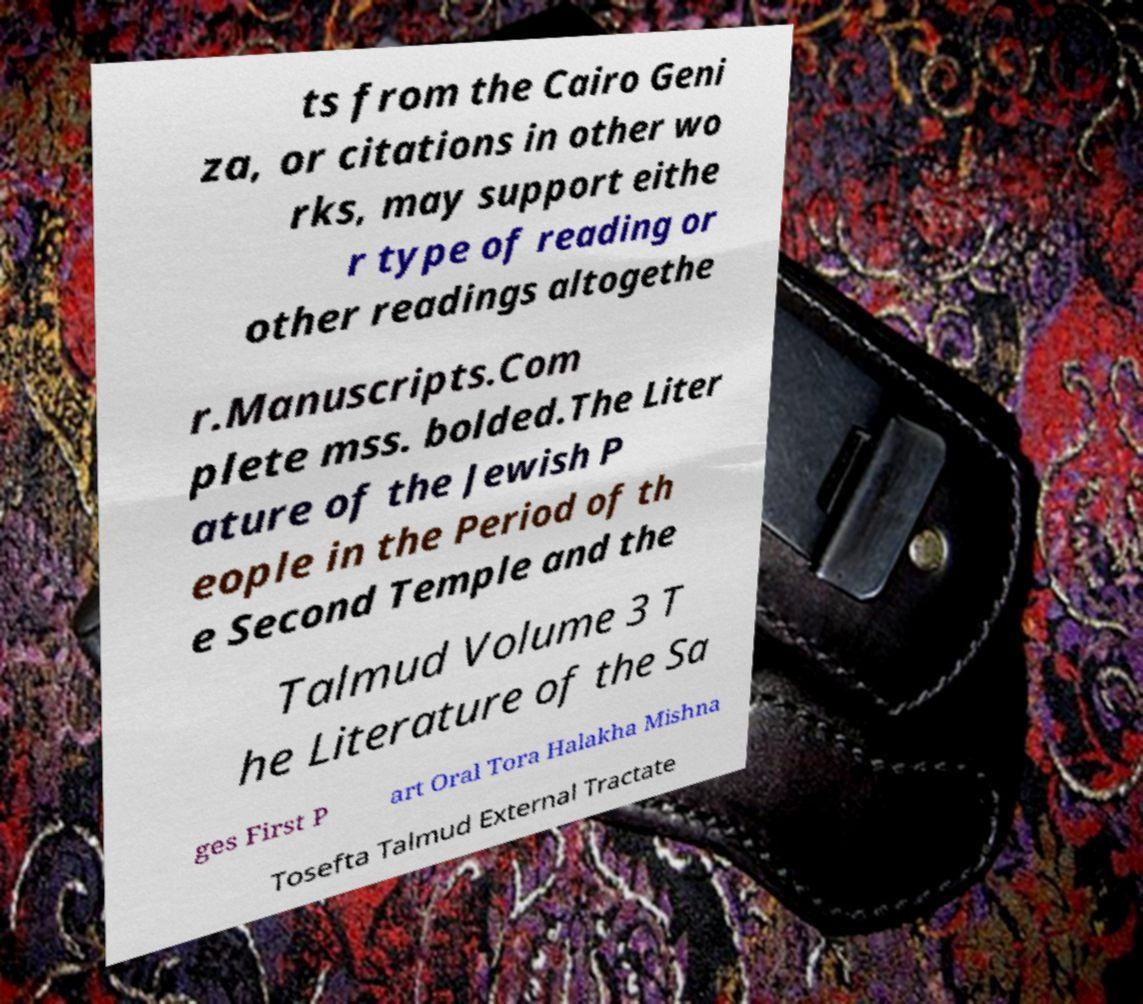Can you accurately transcribe the text from the provided image for me? ts from the Cairo Geni za, or citations in other wo rks, may support eithe r type of reading or other readings altogethe r.Manuscripts.Com plete mss. bolded.The Liter ature of the Jewish P eople in the Period of th e Second Temple and the Talmud Volume 3 T he Literature of the Sa ges First P art Oral Tora Halakha Mishna Tosefta Talmud External Tractate 